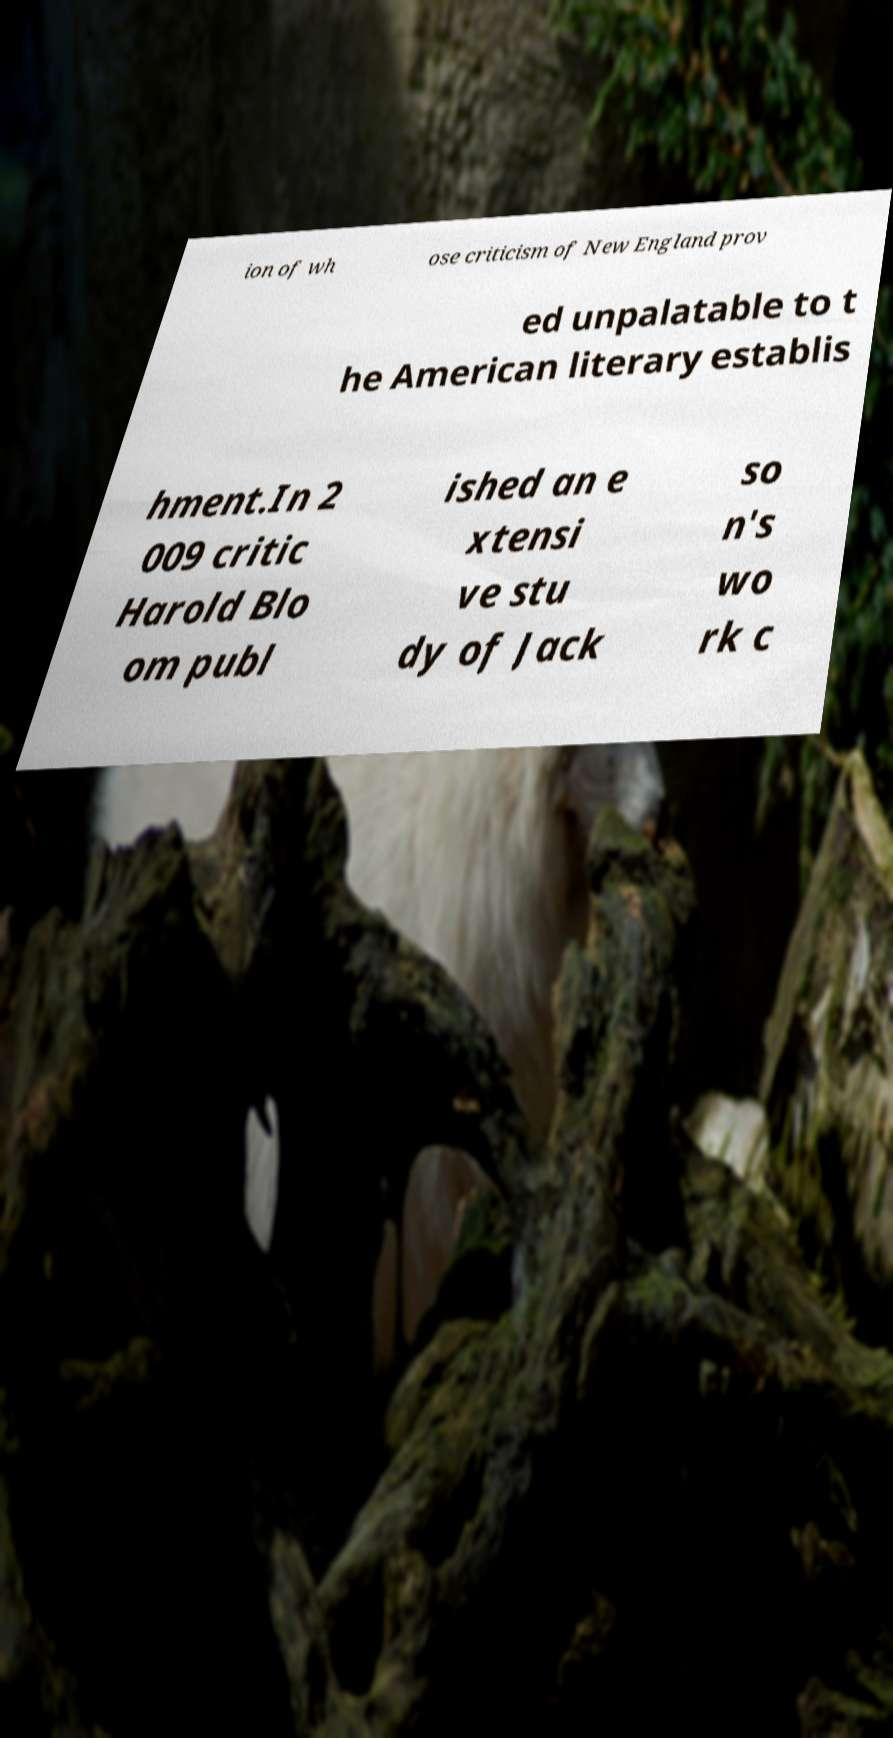Please identify and transcribe the text found in this image. ion of wh ose criticism of New England prov ed unpalatable to t he American literary establis hment.In 2 009 critic Harold Blo om publ ished an e xtensi ve stu dy of Jack so n's wo rk c 